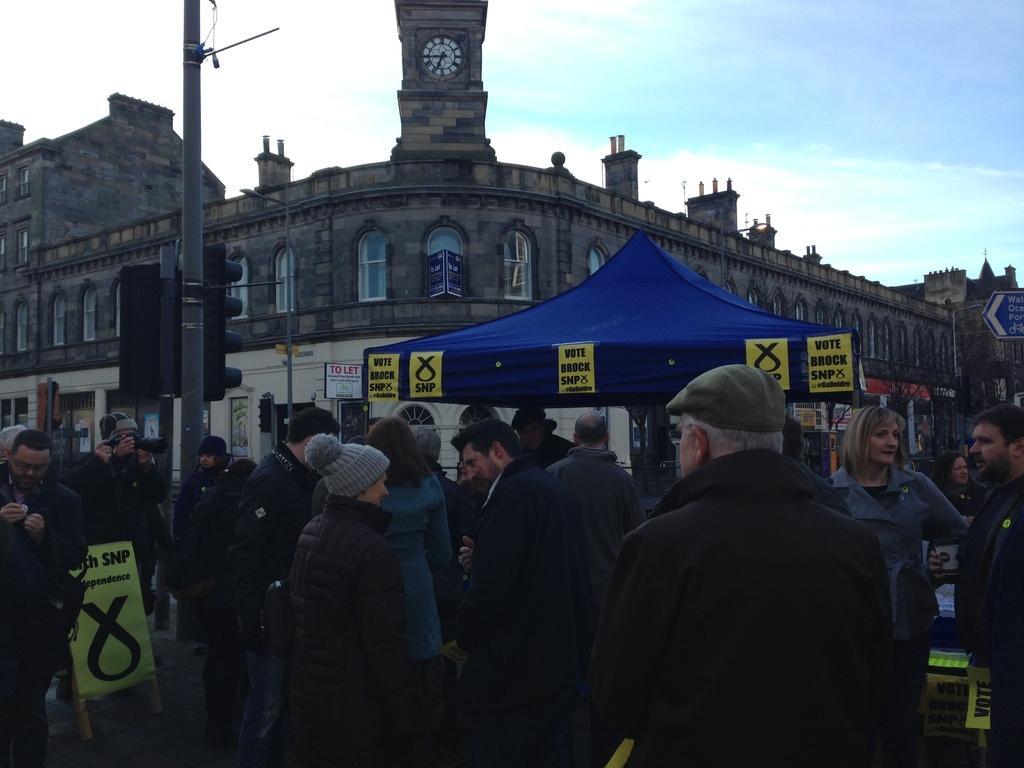In one or two sentences, can you explain what this image depicts? In this picture we can see a group of people, one person is holding a camera, here we can see traffic signals, name boards, posters, tent, trees, poles and in the background we can see a building, sky. 